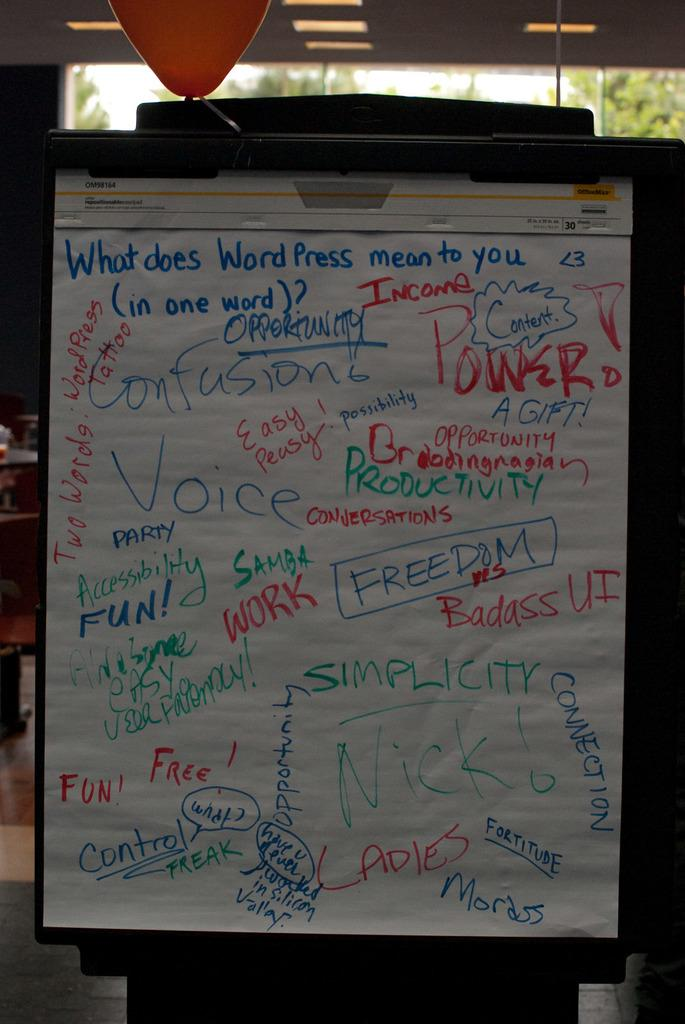<image>
Offer a succinct explanation of the picture presented. Many words on a paper display like power, voice or work 